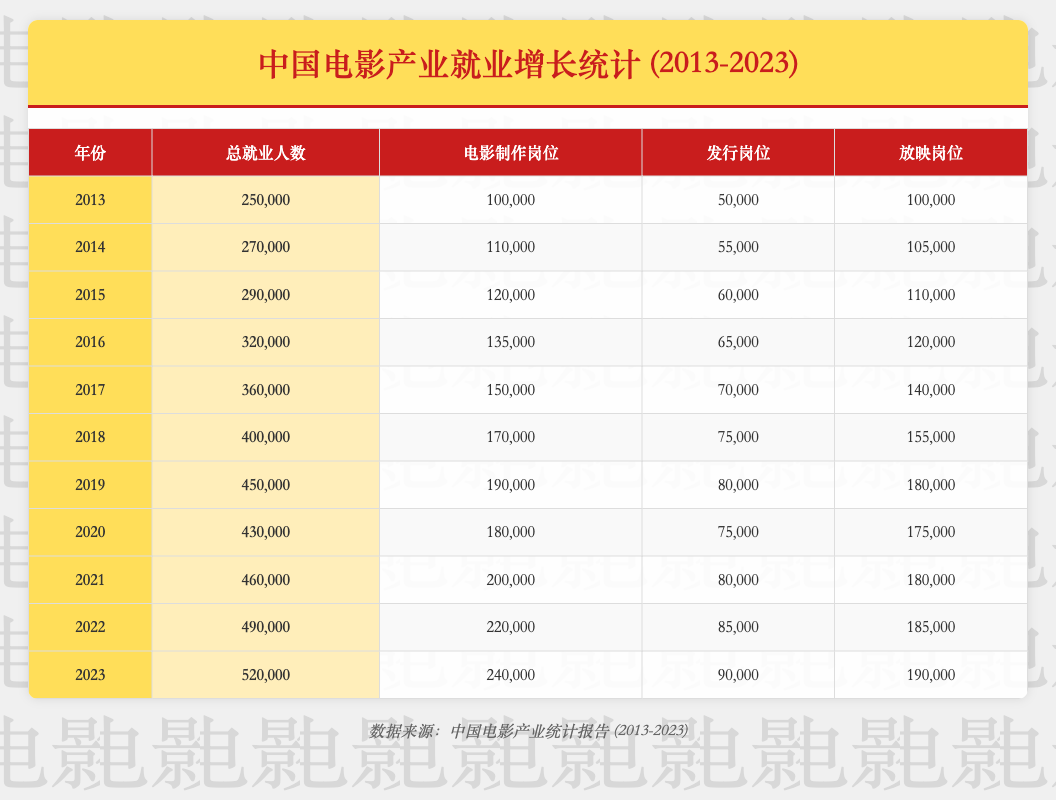What was the total employment in the film industry in 2016? From the table, the entry for the year 2016 states that the total employment in the film industry was 320,000.
Answer: 320,000 Which year had the highest number of film production jobs? The table shows that 2019 had the highest film production jobs at 190,000.
Answer: 2019 What is the difference in total employment between 2022 and 2023? The total employment in 2022 is 490,000, and in 2023 it is 520,000. The difference is 520,000 - 490,000 = 30,000.
Answer: 30,000 Did the number of distribution jobs increase every year? By examining the table, it's clear that the number of distribution jobs did not increase in 2020, where it stayed at 75,000 compared to 80,000 in 2019. Thus, the answer is no.
Answer: No What was the percentage increase in total employment from 2013 to 2023? Total employment in 2013 was 250,000, and in 2023 it was 520,000. The increase is 520,000 - 250,000 = 270,000. The percentage increase is (270,000 / 250,000) * 100 = 108%.
Answer: 108% What is the average number of exhibition jobs from 2013 to 2023? The exhibition job numbers over the years are 100,000, 105,000, 110,000, 120,000, 140,000, 155,000, 180,000, 175,000, 180,000, 185,000, and 190,000. Adding these gives 1,505,000; divided by 11 gives an average of approximately 136,818.
Answer: 136,818 In which year did film exhibition jobs first exceed 150,000? From examining the table, film exhibition jobs first exceeded 150,000 in the year 2018, where it recorded 155,000.
Answer: 2018 What was the total number of jobs in the film industry for the years 2015 and 2016 combined? The total employment in 2015 is 290,000 and in 2016 is 320,000. Adding these yields 290,000 + 320,000 = 610,000.
Answer: 610,000 